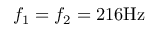<formula> <loc_0><loc_0><loc_500><loc_500>f _ { 1 } = f _ { 2 } = 2 1 6 H z</formula> 